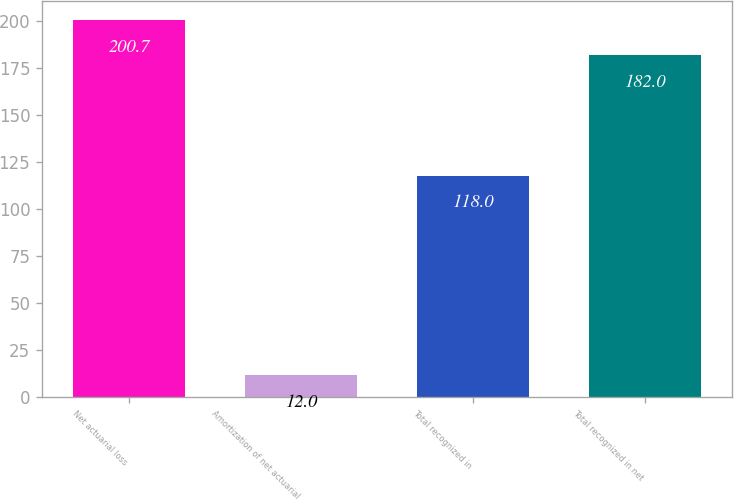<chart> <loc_0><loc_0><loc_500><loc_500><bar_chart><fcel>Net actuarial loss<fcel>Amortization of net actuarial<fcel>Total recognized in<fcel>Total recognized in net<nl><fcel>200.7<fcel>12<fcel>118<fcel>182<nl></chart> 